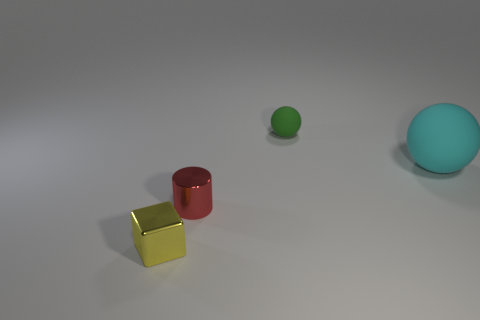Subtract all cyan balls. How many balls are left? 1 Subtract 1 balls. How many balls are left? 1 Add 3 brown matte blocks. How many objects exist? 7 Subtract all cyan balls. How many gray cylinders are left? 0 Subtract all shiny objects. Subtract all large cyan things. How many objects are left? 1 Add 3 tiny matte objects. How many tiny matte objects are left? 4 Add 4 big metallic balls. How many big metallic balls exist? 4 Subtract 0 purple spheres. How many objects are left? 4 Subtract all blue spheres. Subtract all purple cylinders. How many spheres are left? 2 